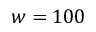<formula> <loc_0><loc_0><loc_500><loc_500>w = 1 0 0</formula> 